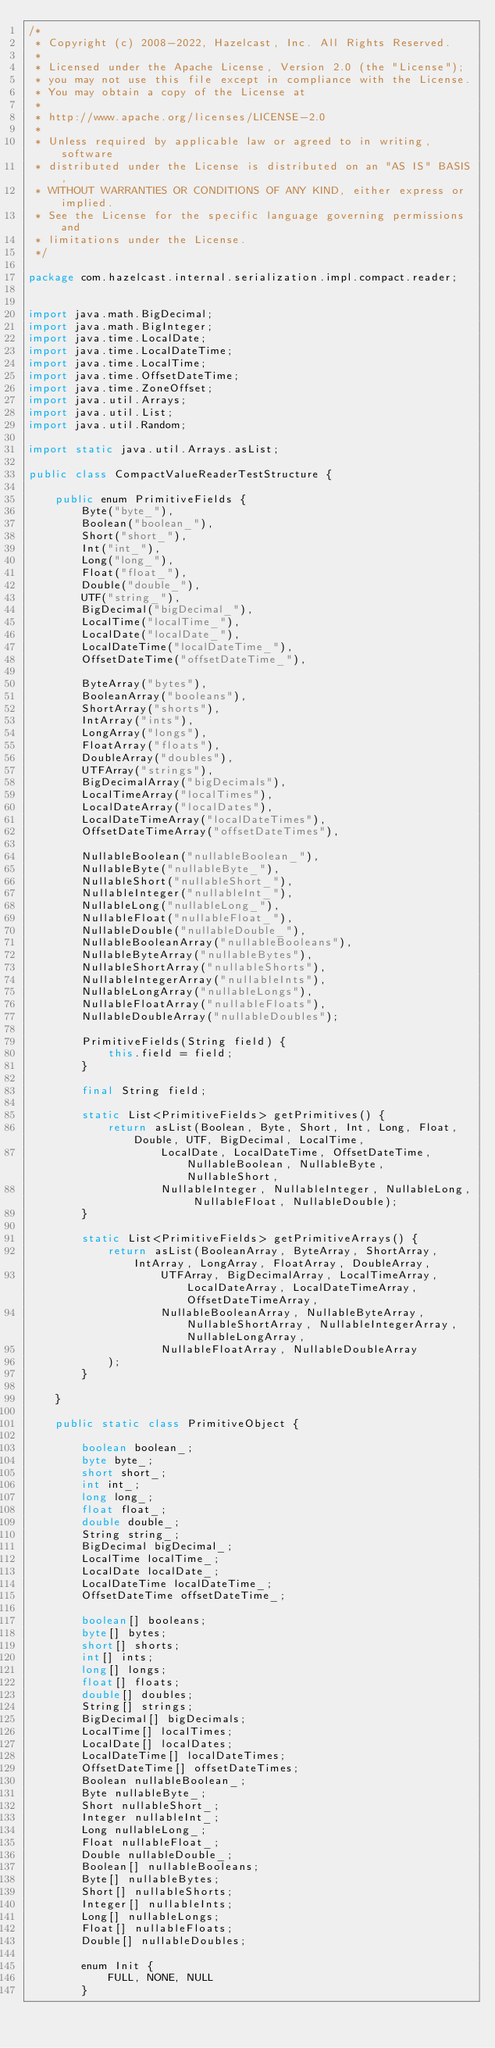<code> <loc_0><loc_0><loc_500><loc_500><_Java_>/*
 * Copyright (c) 2008-2022, Hazelcast, Inc. All Rights Reserved.
 *
 * Licensed under the Apache License, Version 2.0 (the "License");
 * you may not use this file except in compliance with the License.
 * You may obtain a copy of the License at
 *
 * http://www.apache.org/licenses/LICENSE-2.0
 *
 * Unless required by applicable law or agreed to in writing, software
 * distributed under the License is distributed on an "AS IS" BASIS,
 * WITHOUT WARRANTIES OR CONDITIONS OF ANY KIND, either express or implied.
 * See the License for the specific language governing permissions and
 * limitations under the License.
 */

package com.hazelcast.internal.serialization.impl.compact.reader;


import java.math.BigDecimal;
import java.math.BigInteger;
import java.time.LocalDate;
import java.time.LocalDateTime;
import java.time.LocalTime;
import java.time.OffsetDateTime;
import java.time.ZoneOffset;
import java.util.Arrays;
import java.util.List;
import java.util.Random;

import static java.util.Arrays.asList;

public class CompactValueReaderTestStructure {

    public enum PrimitiveFields {
        Byte("byte_"),
        Boolean("boolean_"),
        Short("short_"),
        Int("int_"),
        Long("long_"),
        Float("float_"),
        Double("double_"),
        UTF("string_"),
        BigDecimal("bigDecimal_"),
        LocalTime("localTime_"),
        LocalDate("localDate_"),
        LocalDateTime("localDateTime_"),
        OffsetDateTime("offsetDateTime_"),

        ByteArray("bytes"),
        BooleanArray("booleans"),
        ShortArray("shorts"),
        IntArray("ints"),
        LongArray("longs"),
        FloatArray("floats"),
        DoubleArray("doubles"),
        UTFArray("strings"),
        BigDecimalArray("bigDecimals"),
        LocalTimeArray("localTimes"),
        LocalDateArray("localDates"),
        LocalDateTimeArray("localDateTimes"),
        OffsetDateTimeArray("offsetDateTimes"),

        NullableBoolean("nullableBoolean_"),
        NullableByte("nullableByte_"),
        NullableShort("nullableShort_"),
        NullableInteger("nullableInt_"),
        NullableLong("nullableLong_"),
        NullableFloat("nullableFloat_"),
        NullableDouble("nullableDouble_"),
        NullableBooleanArray("nullableBooleans"),
        NullableByteArray("nullableBytes"),
        NullableShortArray("nullableShorts"),
        NullableIntegerArray("nullableInts"),
        NullableLongArray("nullableLongs"),
        NullableFloatArray("nullableFloats"),
        NullableDoubleArray("nullableDoubles");

        PrimitiveFields(String field) {
            this.field = field;
        }

        final String field;

        static List<PrimitiveFields> getPrimitives() {
            return asList(Boolean, Byte, Short, Int, Long, Float, Double, UTF, BigDecimal, LocalTime,
                    LocalDate, LocalDateTime, OffsetDateTime, NullableBoolean, NullableByte, NullableShort,
                    NullableInteger, NullableInteger, NullableLong, NullableFloat, NullableDouble);
        }

        static List<PrimitiveFields> getPrimitiveArrays() {
            return asList(BooleanArray, ByteArray, ShortArray, IntArray, LongArray, FloatArray, DoubleArray,
                    UTFArray, BigDecimalArray, LocalTimeArray, LocalDateArray, LocalDateTimeArray, OffsetDateTimeArray,
                    NullableBooleanArray, NullableByteArray, NullableShortArray, NullableIntegerArray, NullableLongArray,
                    NullableFloatArray, NullableDoubleArray
            );
        }

    }

    public static class PrimitiveObject {

        boolean boolean_;
        byte byte_;
        short short_;
        int int_;
        long long_;
        float float_;
        double double_;
        String string_;
        BigDecimal bigDecimal_;
        LocalTime localTime_;
        LocalDate localDate_;
        LocalDateTime localDateTime_;
        OffsetDateTime offsetDateTime_;

        boolean[] booleans;
        byte[] bytes;
        short[] shorts;
        int[] ints;
        long[] longs;
        float[] floats;
        double[] doubles;
        String[] strings;
        BigDecimal[] bigDecimals;
        LocalTime[] localTimes;
        LocalDate[] localDates;
        LocalDateTime[] localDateTimes;
        OffsetDateTime[] offsetDateTimes;
        Boolean nullableBoolean_;
        Byte nullableByte_;
        Short nullableShort_;
        Integer nullableInt_;
        Long nullableLong_;
        Float nullableFloat_;
        Double nullableDouble_;
        Boolean[] nullableBooleans;
        Byte[] nullableBytes;
        Short[] nullableShorts;
        Integer[] nullableInts;
        Long[] nullableLongs;
        Float[] nullableFloats;
        Double[] nullableDoubles;

        enum Init {
            FULL, NONE, NULL
        }
</code> 